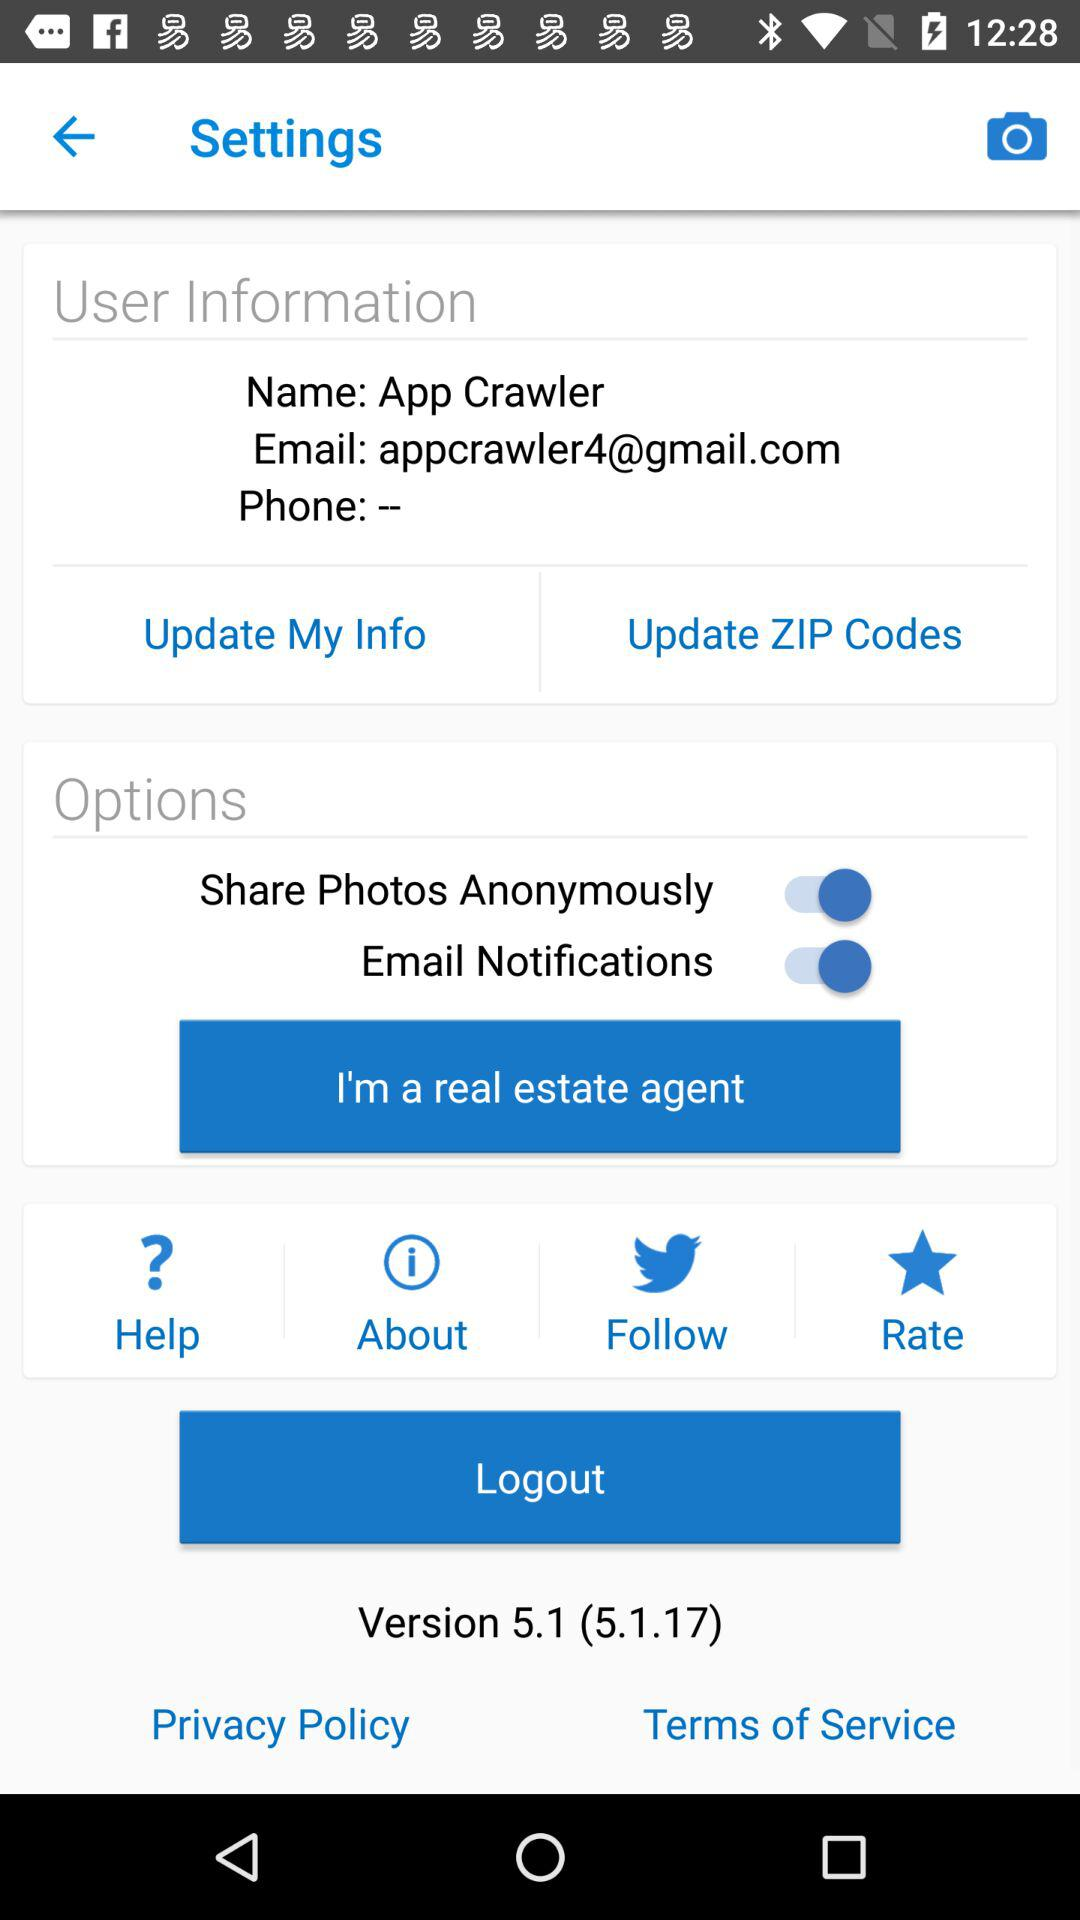How many options are there to update user information?
Answer the question using a single word or phrase. 2 